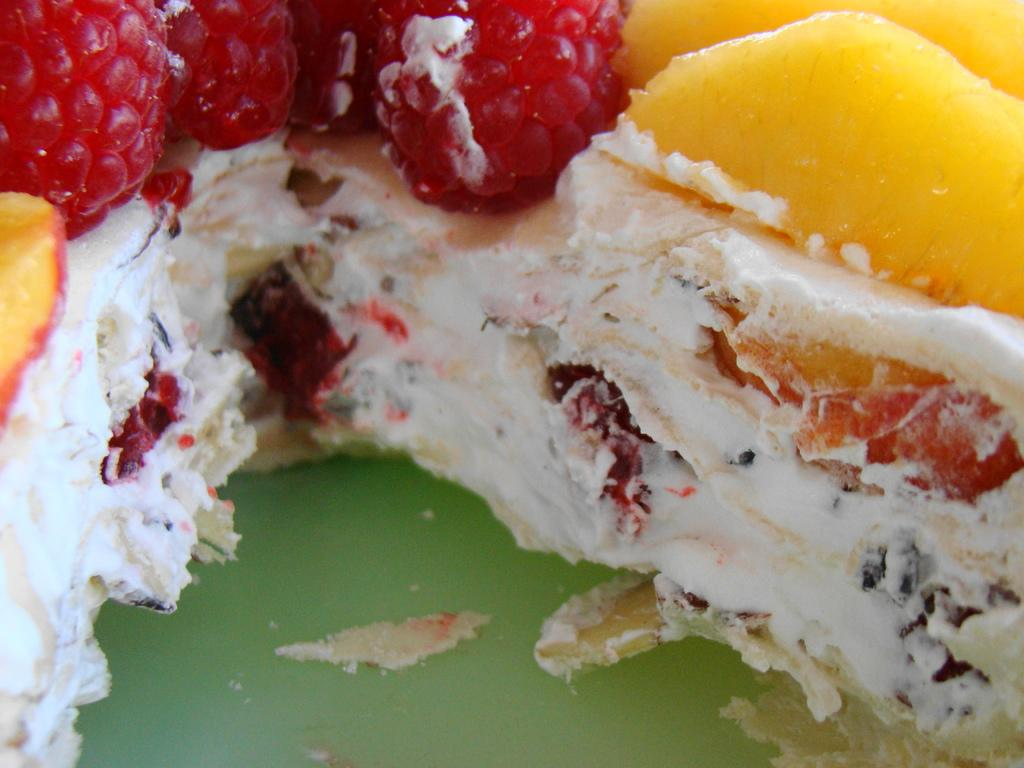What type of food is featured in the image? There is a pastry in the image. What is the color of the pastry? The pastry is white in color. What is placed on top of the pastry? There are raspberries and another fruit on top of the pastry. Can you describe the other fruit on top of the pastry? The other fruit is yellow in color. Is there a flame burning on top of the pastry in the image? No, there is no flame present in the image. 